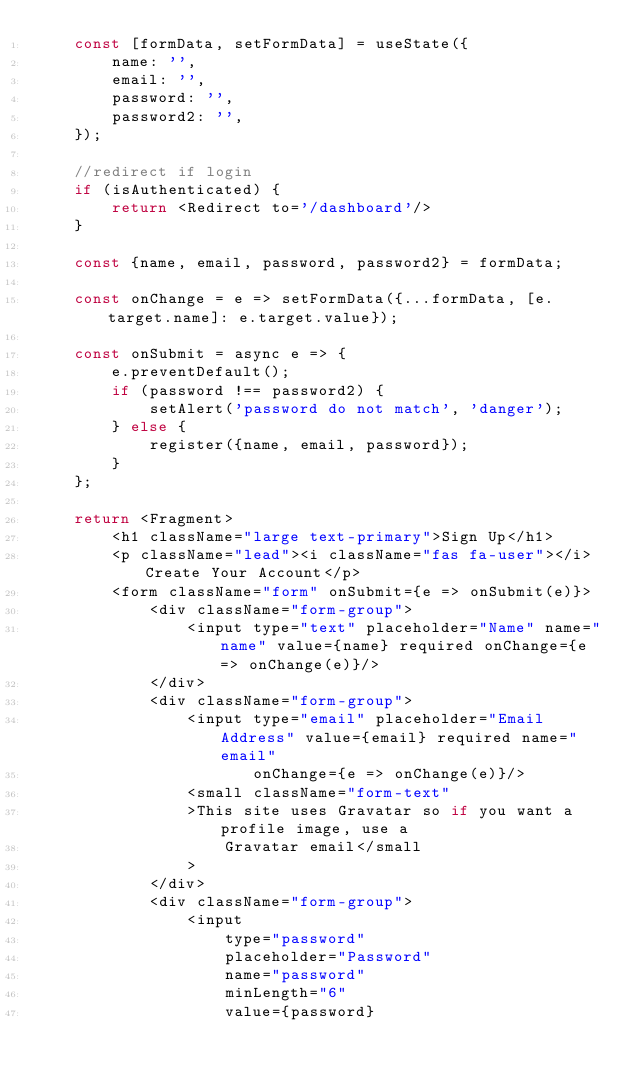Convert code to text. <code><loc_0><loc_0><loc_500><loc_500><_JavaScript_>    const [formData, setFormData] = useState({
        name: '',
        email: '',
        password: '',
        password2: '',
    });

    //redirect if login
    if (isAuthenticated) {
        return <Redirect to='/dashboard'/>
    }

    const {name, email, password, password2} = formData;

    const onChange = e => setFormData({...formData, [e.target.name]: e.target.value});

    const onSubmit = async e => {
        e.preventDefault();
        if (password !== password2) {
            setAlert('password do not match', 'danger');
        } else {
            register({name, email, password});
        }
    };

    return <Fragment>
        <h1 className="large text-primary">Sign Up</h1>
        <p className="lead"><i className="fas fa-user"></i> Create Your Account</p>
        <form className="form" onSubmit={e => onSubmit(e)}>
            <div className="form-group">
                <input type="text" placeholder="Name" name="name" value={name} required onChange={e => onChange(e)}/>
            </div>
            <div className="form-group">
                <input type="email" placeholder="Email Address" value={email} required name="email"
                       onChange={e => onChange(e)}/>
                <small className="form-text"
                >This site uses Gravatar so if you want a profile image, use a
                    Gravatar email</small
                >
            </div>
            <div className="form-group">
                <input
                    type="password"
                    placeholder="Password"
                    name="password"
                    minLength="6"
                    value={password}</code> 